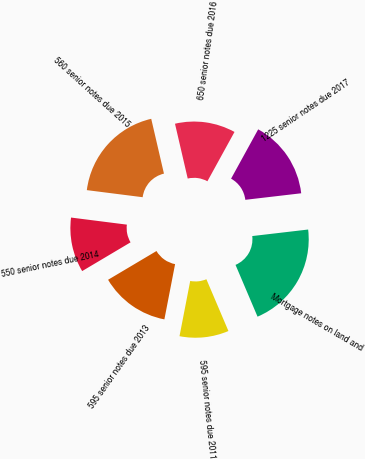<chart> <loc_0><loc_0><loc_500><loc_500><pie_chart><fcel>595 senior notes due 2011<fcel>595 senior notes due 2013<fcel>550 senior notes due 2014<fcel>560 senior notes due 2015<fcel>650 senior notes due 2016<fcel>1225 senior notes due 2017<fcel>Mortgage notes on land and<nl><fcel>9.45%<fcel>13.42%<fcel>10.54%<fcel>19.36%<fcel>11.63%<fcel>15.15%<fcel>20.45%<nl></chart> 